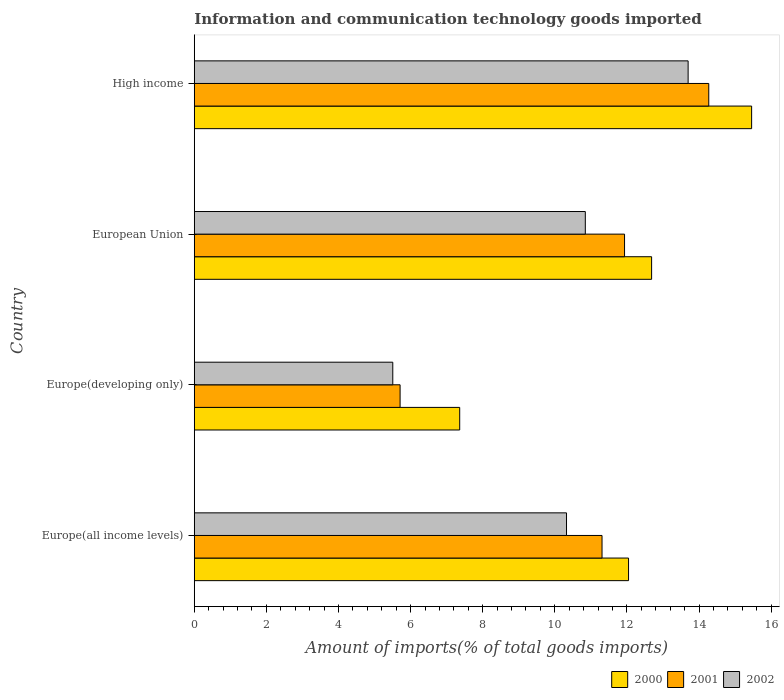How many different coloured bars are there?
Your response must be concise. 3. How many groups of bars are there?
Provide a short and direct response. 4. Are the number of bars on each tick of the Y-axis equal?
Your response must be concise. Yes. How many bars are there on the 2nd tick from the bottom?
Keep it short and to the point. 3. What is the label of the 4th group of bars from the top?
Keep it short and to the point. Europe(all income levels). In how many cases, is the number of bars for a given country not equal to the number of legend labels?
Offer a very short reply. 0. What is the amount of goods imported in 2001 in Europe(all income levels)?
Your response must be concise. 11.31. Across all countries, what is the maximum amount of goods imported in 2002?
Ensure brevity in your answer.  13.7. Across all countries, what is the minimum amount of goods imported in 2001?
Your answer should be compact. 5.71. In which country was the amount of goods imported in 2001 maximum?
Offer a very short reply. High income. In which country was the amount of goods imported in 2000 minimum?
Make the answer very short. Europe(developing only). What is the total amount of goods imported in 2001 in the graph?
Offer a terse response. 43.22. What is the difference between the amount of goods imported in 2002 in Europe(all income levels) and that in Europe(developing only)?
Your answer should be compact. 4.82. What is the difference between the amount of goods imported in 2000 in Europe(all income levels) and the amount of goods imported in 2002 in Europe(developing only)?
Offer a terse response. 6.54. What is the average amount of goods imported in 2002 per country?
Your response must be concise. 10.09. What is the difference between the amount of goods imported in 2000 and amount of goods imported in 2002 in Europe(developing only)?
Your answer should be very brief. 1.86. What is the ratio of the amount of goods imported in 2001 in European Union to that in High income?
Your answer should be compact. 0.84. Is the difference between the amount of goods imported in 2000 in Europe(all income levels) and Europe(developing only) greater than the difference between the amount of goods imported in 2002 in Europe(all income levels) and Europe(developing only)?
Offer a terse response. No. What is the difference between the highest and the second highest amount of goods imported in 2002?
Your response must be concise. 2.85. What is the difference between the highest and the lowest amount of goods imported in 2000?
Your response must be concise. 8.1. What does the 2nd bar from the bottom in European Union represents?
Your answer should be compact. 2001. Is it the case that in every country, the sum of the amount of goods imported in 2001 and amount of goods imported in 2002 is greater than the amount of goods imported in 2000?
Give a very brief answer. Yes. What is the difference between two consecutive major ticks on the X-axis?
Provide a short and direct response. 2. Are the values on the major ticks of X-axis written in scientific E-notation?
Give a very brief answer. No. Does the graph contain grids?
Your answer should be very brief. No. Where does the legend appear in the graph?
Offer a terse response. Bottom right. How are the legend labels stacked?
Your response must be concise. Horizontal. What is the title of the graph?
Give a very brief answer. Information and communication technology goods imported. What is the label or title of the X-axis?
Provide a short and direct response. Amount of imports(% of total goods imports). What is the label or title of the Y-axis?
Your response must be concise. Country. What is the Amount of imports(% of total goods imports) in 2000 in Europe(all income levels)?
Your response must be concise. 12.04. What is the Amount of imports(% of total goods imports) of 2001 in Europe(all income levels)?
Your answer should be very brief. 11.31. What is the Amount of imports(% of total goods imports) of 2002 in Europe(all income levels)?
Provide a short and direct response. 10.32. What is the Amount of imports(% of total goods imports) in 2000 in Europe(developing only)?
Keep it short and to the point. 7.36. What is the Amount of imports(% of total goods imports) in 2001 in Europe(developing only)?
Your answer should be compact. 5.71. What is the Amount of imports(% of total goods imports) in 2002 in Europe(developing only)?
Give a very brief answer. 5.51. What is the Amount of imports(% of total goods imports) in 2000 in European Union?
Your response must be concise. 12.68. What is the Amount of imports(% of total goods imports) of 2001 in European Union?
Provide a short and direct response. 11.93. What is the Amount of imports(% of total goods imports) in 2002 in European Union?
Provide a short and direct response. 10.85. What is the Amount of imports(% of total goods imports) in 2000 in High income?
Provide a short and direct response. 15.46. What is the Amount of imports(% of total goods imports) of 2001 in High income?
Your answer should be very brief. 14.27. What is the Amount of imports(% of total goods imports) in 2002 in High income?
Make the answer very short. 13.7. Across all countries, what is the maximum Amount of imports(% of total goods imports) in 2000?
Your answer should be compact. 15.46. Across all countries, what is the maximum Amount of imports(% of total goods imports) of 2001?
Offer a terse response. 14.27. Across all countries, what is the maximum Amount of imports(% of total goods imports) of 2002?
Provide a succinct answer. 13.7. Across all countries, what is the minimum Amount of imports(% of total goods imports) in 2000?
Make the answer very short. 7.36. Across all countries, what is the minimum Amount of imports(% of total goods imports) of 2001?
Ensure brevity in your answer.  5.71. Across all countries, what is the minimum Amount of imports(% of total goods imports) of 2002?
Offer a terse response. 5.51. What is the total Amount of imports(% of total goods imports) of 2000 in the graph?
Your answer should be very brief. 47.55. What is the total Amount of imports(% of total goods imports) in 2001 in the graph?
Give a very brief answer. 43.22. What is the total Amount of imports(% of total goods imports) in 2002 in the graph?
Your answer should be very brief. 40.37. What is the difference between the Amount of imports(% of total goods imports) of 2000 in Europe(all income levels) and that in Europe(developing only)?
Provide a short and direct response. 4.68. What is the difference between the Amount of imports(% of total goods imports) of 2001 in Europe(all income levels) and that in Europe(developing only)?
Provide a succinct answer. 5.6. What is the difference between the Amount of imports(% of total goods imports) in 2002 in Europe(all income levels) and that in Europe(developing only)?
Your answer should be very brief. 4.82. What is the difference between the Amount of imports(% of total goods imports) of 2000 in Europe(all income levels) and that in European Union?
Your answer should be compact. -0.64. What is the difference between the Amount of imports(% of total goods imports) of 2001 in Europe(all income levels) and that in European Union?
Offer a terse response. -0.62. What is the difference between the Amount of imports(% of total goods imports) in 2002 in Europe(all income levels) and that in European Union?
Keep it short and to the point. -0.52. What is the difference between the Amount of imports(% of total goods imports) of 2000 in Europe(all income levels) and that in High income?
Provide a short and direct response. -3.41. What is the difference between the Amount of imports(% of total goods imports) in 2001 in Europe(all income levels) and that in High income?
Make the answer very short. -2.96. What is the difference between the Amount of imports(% of total goods imports) of 2002 in Europe(all income levels) and that in High income?
Offer a terse response. -3.37. What is the difference between the Amount of imports(% of total goods imports) in 2000 in Europe(developing only) and that in European Union?
Your response must be concise. -5.32. What is the difference between the Amount of imports(% of total goods imports) in 2001 in Europe(developing only) and that in European Union?
Make the answer very short. -6.22. What is the difference between the Amount of imports(% of total goods imports) in 2002 in Europe(developing only) and that in European Union?
Provide a short and direct response. -5.34. What is the difference between the Amount of imports(% of total goods imports) of 2000 in Europe(developing only) and that in High income?
Offer a very short reply. -8.1. What is the difference between the Amount of imports(% of total goods imports) in 2001 in Europe(developing only) and that in High income?
Ensure brevity in your answer.  -8.56. What is the difference between the Amount of imports(% of total goods imports) in 2002 in Europe(developing only) and that in High income?
Ensure brevity in your answer.  -8.19. What is the difference between the Amount of imports(% of total goods imports) in 2000 in European Union and that in High income?
Give a very brief answer. -2.77. What is the difference between the Amount of imports(% of total goods imports) of 2001 in European Union and that in High income?
Provide a succinct answer. -2.34. What is the difference between the Amount of imports(% of total goods imports) in 2002 in European Union and that in High income?
Provide a succinct answer. -2.85. What is the difference between the Amount of imports(% of total goods imports) of 2000 in Europe(all income levels) and the Amount of imports(% of total goods imports) of 2001 in Europe(developing only)?
Provide a short and direct response. 6.34. What is the difference between the Amount of imports(% of total goods imports) in 2000 in Europe(all income levels) and the Amount of imports(% of total goods imports) in 2002 in Europe(developing only)?
Offer a terse response. 6.54. What is the difference between the Amount of imports(% of total goods imports) of 2001 in Europe(all income levels) and the Amount of imports(% of total goods imports) of 2002 in Europe(developing only)?
Keep it short and to the point. 5.8. What is the difference between the Amount of imports(% of total goods imports) of 2000 in Europe(all income levels) and the Amount of imports(% of total goods imports) of 2001 in European Union?
Provide a short and direct response. 0.11. What is the difference between the Amount of imports(% of total goods imports) of 2000 in Europe(all income levels) and the Amount of imports(% of total goods imports) of 2002 in European Union?
Provide a succinct answer. 1.2. What is the difference between the Amount of imports(% of total goods imports) of 2001 in Europe(all income levels) and the Amount of imports(% of total goods imports) of 2002 in European Union?
Your answer should be compact. 0.46. What is the difference between the Amount of imports(% of total goods imports) in 2000 in Europe(all income levels) and the Amount of imports(% of total goods imports) in 2001 in High income?
Offer a terse response. -2.22. What is the difference between the Amount of imports(% of total goods imports) of 2000 in Europe(all income levels) and the Amount of imports(% of total goods imports) of 2002 in High income?
Your answer should be compact. -1.65. What is the difference between the Amount of imports(% of total goods imports) of 2001 in Europe(all income levels) and the Amount of imports(% of total goods imports) of 2002 in High income?
Your answer should be compact. -2.39. What is the difference between the Amount of imports(% of total goods imports) of 2000 in Europe(developing only) and the Amount of imports(% of total goods imports) of 2001 in European Union?
Your answer should be very brief. -4.57. What is the difference between the Amount of imports(% of total goods imports) of 2000 in Europe(developing only) and the Amount of imports(% of total goods imports) of 2002 in European Union?
Offer a terse response. -3.48. What is the difference between the Amount of imports(% of total goods imports) in 2001 in Europe(developing only) and the Amount of imports(% of total goods imports) in 2002 in European Union?
Offer a very short reply. -5.14. What is the difference between the Amount of imports(% of total goods imports) in 2000 in Europe(developing only) and the Amount of imports(% of total goods imports) in 2001 in High income?
Keep it short and to the point. -6.91. What is the difference between the Amount of imports(% of total goods imports) in 2000 in Europe(developing only) and the Amount of imports(% of total goods imports) in 2002 in High income?
Your response must be concise. -6.34. What is the difference between the Amount of imports(% of total goods imports) of 2001 in Europe(developing only) and the Amount of imports(% of total goods imports) of 2002 in High income?
Ensure brevity in your answer.  -7.99. What is the difference between the Amount of imports(% of total goods imports) in 2000 in European Union and the Amount of imports(% of total goods imports) in 2001 in High income?
Provide a succinct answer. -1.59. What is the difference between the Amount of imports(% of total goods imports) in 2000 in European Union and the Amount of imports(% of total goods imports) in 2002 in High income?
Give a very brief answer. -1.01. What is the difference between the Amount of imports(% of total goods imports) in 2001 in European Union and the Amount of imports(% of total goods imports) in 2002 in High income?
Give a very brief answer. -1.76. What is the average Amount of imports(% of total goods imports) of 2000 per country?
Provide a succinct answer. 11.89. What is the average Amount of imports(% of total goods imports) of 2001 per country?
Your response must be concise. 10.81. What is the average Amount of imports(% of total goods imports) in 2002 per country?
Provide a succinct answer. 10.09. What is the difference between the Amount of imports(% of total goods imports) in 2000 and Amount of imports(% of total goods imports) in 2001 in Europe(all income levels)?
Give a very brief answer. 0.74. What is the difference between the Amount of imports(% of total goods imports) in 2000 and Amount of imports(% of total goods imports) in 2002 in Europe(all income levels)?
Offer a very short reply. 1.72. What is the difference between the Amount of imports(% of total goods imports) of 2001 and Amount of imports(% of total goods imports) of 2002 in Europe(all income levels)?
Offer a terse response. 0.98. What is the difference between the Amount of imports(% of total goods imports) of 2000 and Amount of imports(% of total goods imports) of 2001 in Europe(developing only)?
Ensure brevity in your answer.  1.65. What is the difference between the Amount of imports(% of total goods imports) in 2000 and Amount of imports(% of total goods imports) in 2002 in Europe(developing only)?
Provide a succinct answer. 1.86. What is the difference between the Amount of imports(% of total goods imports) in 2001 and Amount of imports(% of total goods imports) in 2002 in Europe(developing only)?
Ensure brevity in your answer.  0.2. What is the difference between the Amount of imports(% of total goods imports) in 2000 and Amount of imports(% of total goods imports) in 2001 in European Union?
Your answer should be compact. 0.75. What is the difference between the Amount of imports(% of total goods imports) of 2000 and Amount of imports(% of total goods imports) of 2002 in European Union?
Give a very brief answer. 1.84. What is the difference between the Amount of imports(% of total goods imports) in 2001 and Amount of imports(% of total goods imports) in 2002 in European Union?
Offer a very short reply. 1.09. What is the difference between the Amount of imports(% of total goods imports) in 2000 and Amount of imports(% of total goods imports) in 2001 in High income?
Ensure brevity in your answer.  1.19. What is the difference between the Amount of imports(% of total goods imports) in 2000 and Amount of imports(% of total goods imports) in 2002 in High income?
Ensure brevity in your answer.  1.76. What is the difference between the Amount of imports(% of total goods imports) of 2001 and Amount of imports(% of total goods imports) of 2002 in High income?
Offer a very short reply. 0.57. What is the ratio of the Amount of imports(% of total goods imports) in 2000 in Europe(all income levels) to that in Europe(developing only)?
Your response must be concise. 1.64. What is the ratio of the Amount of imports(% of total goods imports) of 2001 in Europe(all income levels) to that in Europe(developing only)?
Provide a short and direct response. 1.98. What is the ratio of the Amount of imports(% of total goods imports) in 2002 in Europe(all income levels) to that in Europe(developing only)?
Make the answer very short. 1.88. What is the ratio of the Amount of imports(% of total goods imports) in 2000 in Europe(all income levels) to that in European Union?
Keep it short and to the point. 0.95. What is the ratio of the Amount of imports(% of total goods imports) of 2001 in Europe(all income levels) to that in European Union?
Provide a succinct answer. 0.95. What is the ratio of the Amount of imports(% of total goods imports) of 2002 in Europe(all income levels) to that in European Union?
Keep it short and to the point. 0.95. What is the ratio of the Amount of imports(% of total goods imports) in 2000 in Europe(all income levels) to that in High income?
Ensure brevity in your answer.  0.78. What is the ratio of the Amount of imports(% of total goods imports) in 2001 in Europe(all income levels) to that in High income?
Your answer should be very brief. 0.79. What is the ratio of the Amount of imports(% of total goods imports) of 2002 in Europe(all income levels) to that in High income?
Offer a terse response. 0.75. What is the ratio of the Amount of imports(% of total goods imports) in 2000 in Europe(developing only) to that in European Union?
Keep it short and to the point. 0.58. What is the ratio of the Amount of imports(% of total goods imports) of 2001 in Europe(developing only) to that in European Union?
Ensure brevity in your answer.  0.48. What is the ratio of the Amount of imports(% of total goods imports) in 2002 in Europe(developing only) to that in European Union?
Make the answer very short. 0.51. What is the ratio of the Amount of imports(% of total goods imports) in 2000 in Europe(developing only) to that in High income?
Ensure brevity in your answer.  0.48. What is the ratio of the Amount of imports(% of total goods imports) in 2001 in Europe(developing only) to that in High income?
Provide a short and direct response. 0.4. What is the ratio of the Amount of imports(% of total goods imports) of 2002 in Europe(developing only) to that in High income?
Give a very brief answer. 0.4. What is the ratio of the Amount of imports(% of total goods imports) of 2000 in European Union to that in High income?
Your response must be concise. 0.82. What is the ratio of the Amount of imports(% of total goods imports) in 2001 in European Union to that in High income?
Offer a terse response. 0.84. What is the ratio of the Amount of imports(% of total goods imports) in 2002 in European Union to that in High income?
Provide a succinct answer. 0.79. What is the difference between the highest and the second highest Amount of imports(% of total goods imports) in 2000?
Your response must be concise. 2.77. What is the difference between the highest and the second highest Amount of imports(% of total goods imports) in 2001?
Ensure brevity in your answer.  2.34. What is the difference between the highest and the second highest Amount of imports(% of total goods imports) of 2002?
Provide a succinct answer. 2.85. What is the difference between the highest and the lowest Amount of imports(% of total goods imports) in 2000?
Provide a succinct answer. 8.1. What is the difference between the highest and the lowest Amount of imports(% of total goods imports) of 2001?
Your answer should be compact. 8.56. What is the difference between the highest and the lowest Amount of imports(% of total goods imports) of 2002?
Give a very brief answer. 8.19. 